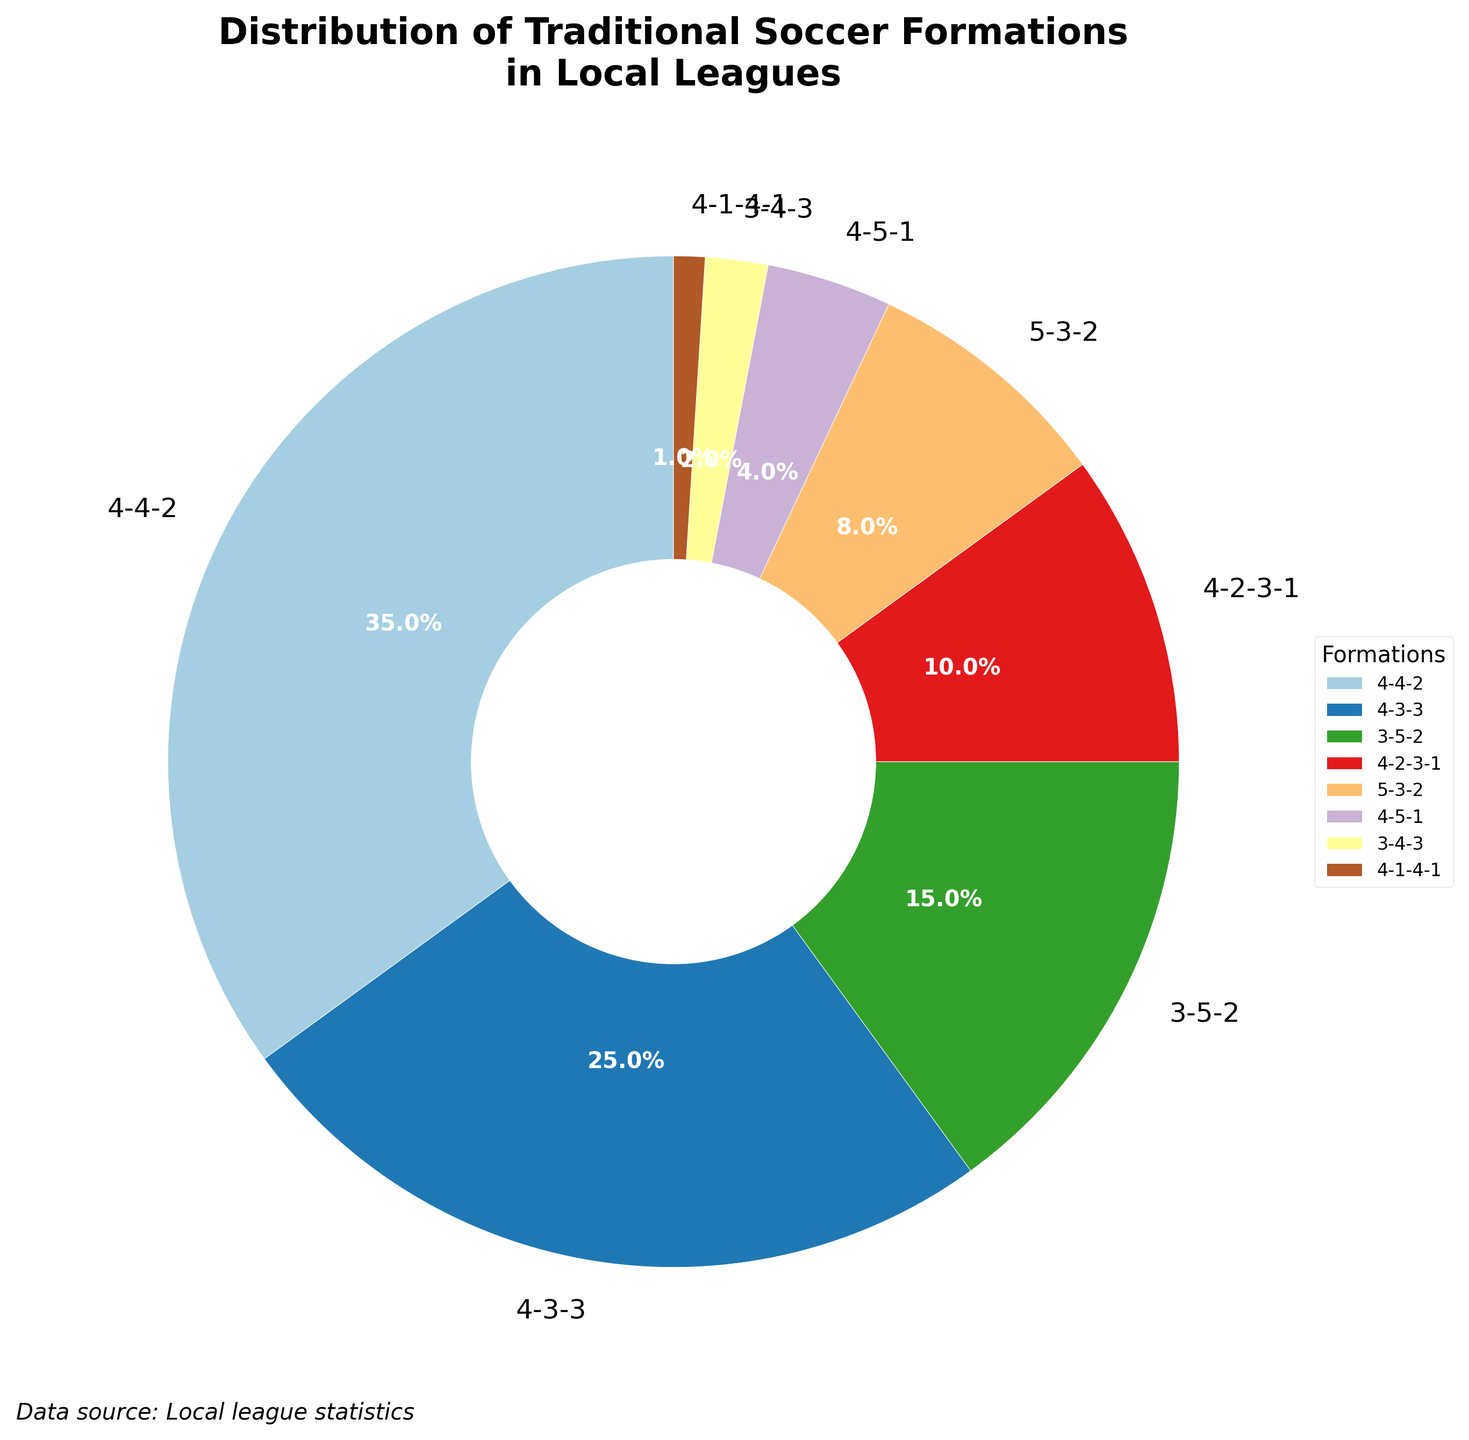Which soccer formation is the most popular in local leagues? The pie chart shows the distribution of traditional soccer formations. The largest segment represents the most popular formation.
Answer: 4-4-2 What percentage of teams use a 4-3-3 formation? The pie chart has percentages labeled for each formation. Look for the 4-3-3 label and note its percentage.
Answer: 25% How do the combined percentages of 3-5-2 and 4-2-3-1 formations compare to the percentage of the 4-3-3 formation? Add the percentages of 3-5-2 (15%) and 4-2-3-1 (10%) and compare this to 4-3-3 (25%).
Answer: Equal What is the least popular soccer formation in local leagues and what percentage of teams use it? Check the smallest segment in the pie chart and note its formation and percentage.
Answer: 4-1-4-1, 1% How much more popular is the 4-4-2 formation compared to the 5-3-2 formation? Subtract the percentage of 5-3-2 (8%) from the percentage of 4-4-2 (35%).
Answer: 27% What is the combined percentage of teams using either a 4-5-1 or 3-4-3 formation? Add the percentages of 4-5-1 (4%) and 3-4-3 (2%).
Answer: 6% Is the percentage of teams using 4-1-4-1 formation the same as the combined percentage of teams using 4-5-1 and 3-4-3 formations? Compare the percentage of 4-1-4-1 (1%) with the sum of 4-5-1 (4%) and 3-4-3 (2%), which is 6%.
Answer: No Which three formations make up more than half of the teams combined? Add the percentages of the largest segments until the sum exceeds 50%.
Answer: 4-4-2, 4-3-3, 3-5-2 What is the percentage difference between 4-2-3-1 and 4-5-1 formations? Subtract the percentage of 4-5-1 (4%) from 4-2-3-1 (10%).
Answer: 6% How does the color pattern help quickly identify the more popular formations? The more popular formations typically have larger, brighter segments in the pie chart, making them more visually noticeable.
Answer: Larger, brighter segments 